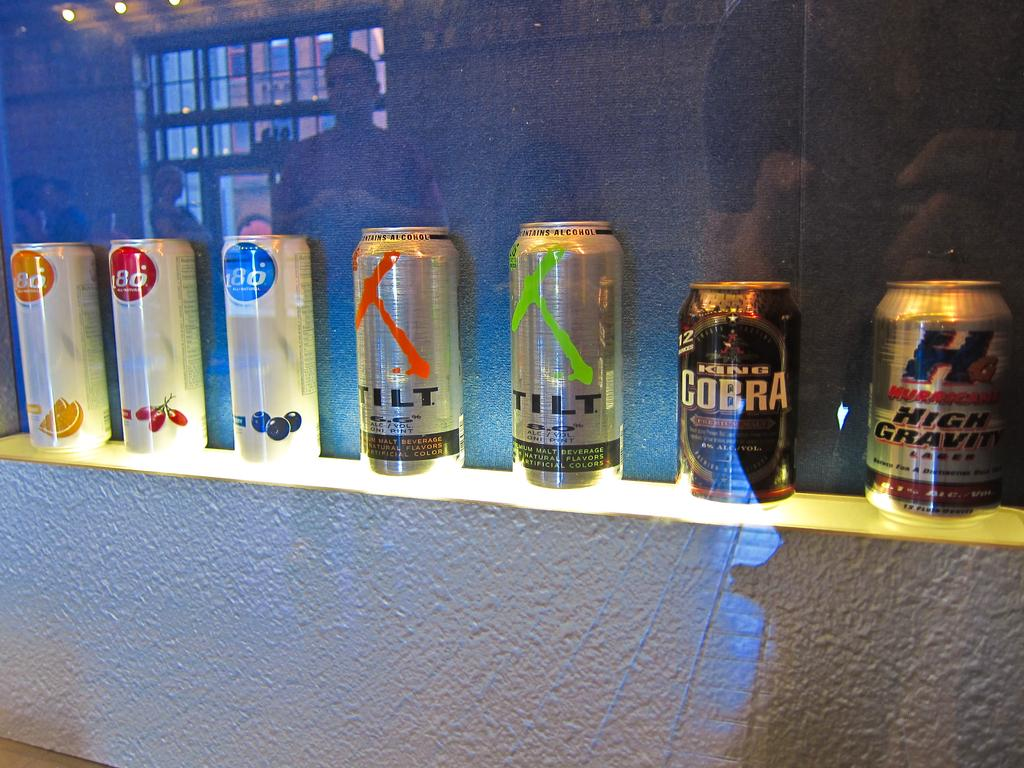<image>
Render a clear and concise summary of the photo. seven cans  of beer and three of them have the number 80. 